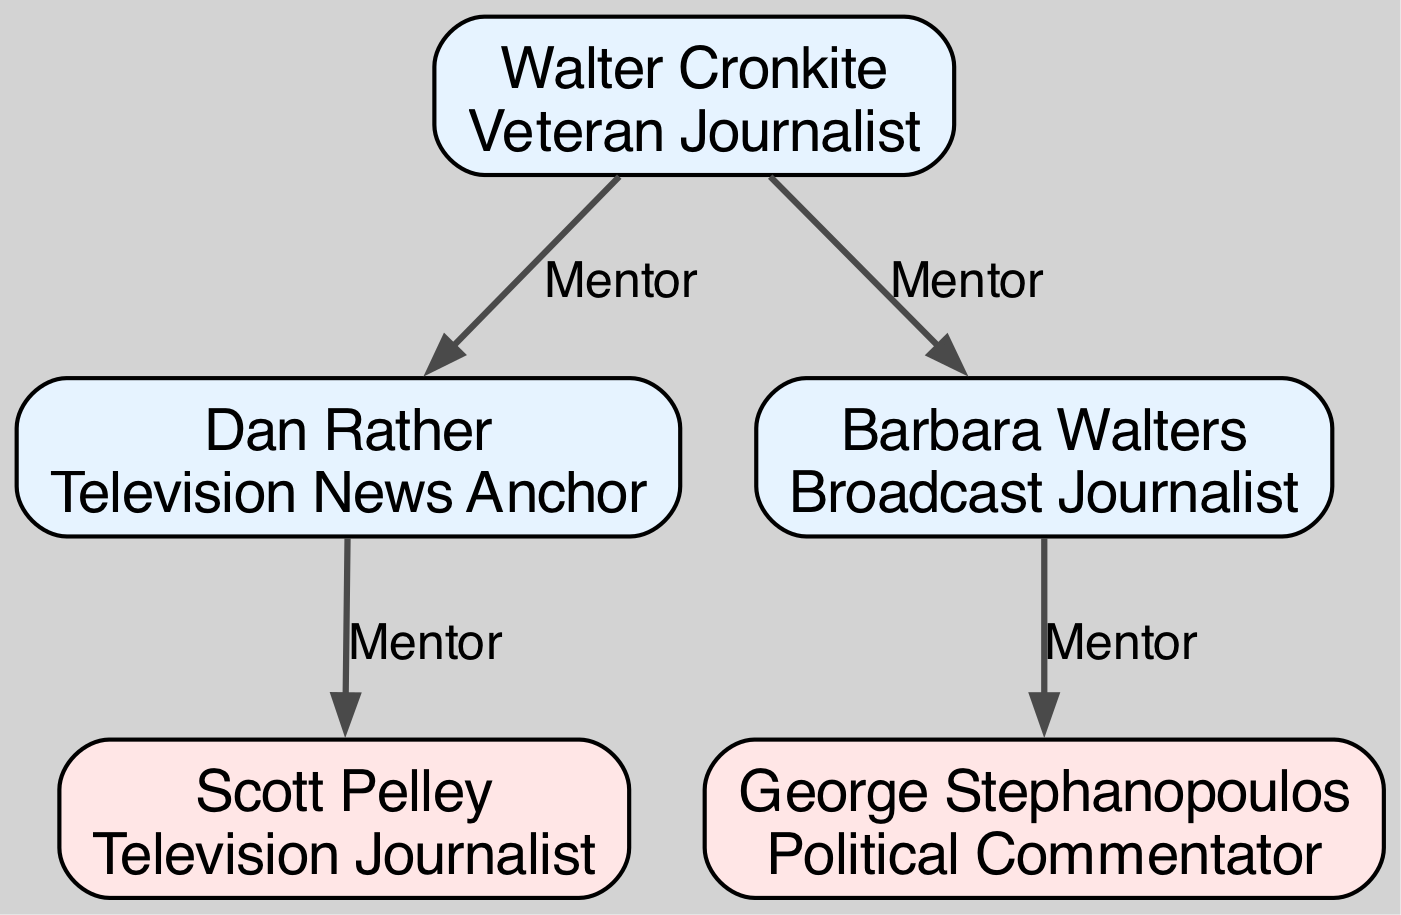What is the total number of nodes in the diagram? The diagram lists five nodes, each representing a different individual involved in the influence network of political analysts and their mentors.
Answer: 5 Who is identified as the mentor of Dan Rather? The diagram indicates that Walter Cronkite serves as the mentor for Dan Rather, as there is a directed edge from Cronkite to Rather labeled "Mentor."
Answer: Walter Cronkite How many individuals are mentored by Barbara Walters? There is only one individual mentioned in the diagram who is mentored by Barbara Walters, which is George Stephanopoulos, who has a directed edge from Walters.
Answer: 1 Which political commentator is influenced by Scott Pelley? The diagram shows that Scott Pelley does not influence any individuals, as he has no outgoing directed edges. Therefore, the answer is that there is no political commentator influenced by him.
Answer: None Who are the two individuals mentored by Walter Cronkite? The diagram reveals that Dan Rather and Barbara Walters are the two individuals who are mentored by Walter Cronkite, as indicated by the connections leading from Cronkite to each of them labeled "Mentor."
Answer: Dan Rather, Barbara Walters What is the direct relationship between George Stephanopoulos and Barbara Walters? The diagram indicates that Barbara Walters is the mentor of George Stephanopoulos, as shown by a directed edge leading from Walters to Stephanopoulos, labeled "Mentor."
Answer: Mentor Which node has the most influences? Analyzing the edges leading from the nodes shows that both Dan Rather and Barbara Walters are influenced by Walter Cronkite, making him the node with the most direct influence on others.
Answer: Walter Cronkite How many mentors does Scott Pelley have? The diagram illustrates that Scott Pelley is only mentored by Dan Rather with a directed edge going from Rather to Pelley, indicating he has one mentor.
Answer: 1 What role does George Stephanopoulos play in the diagram? The diagram specifies that George Stephanopoulos is identified as a Political Commentator, as indicated in his node's role description.
Answer: Political Commentator 